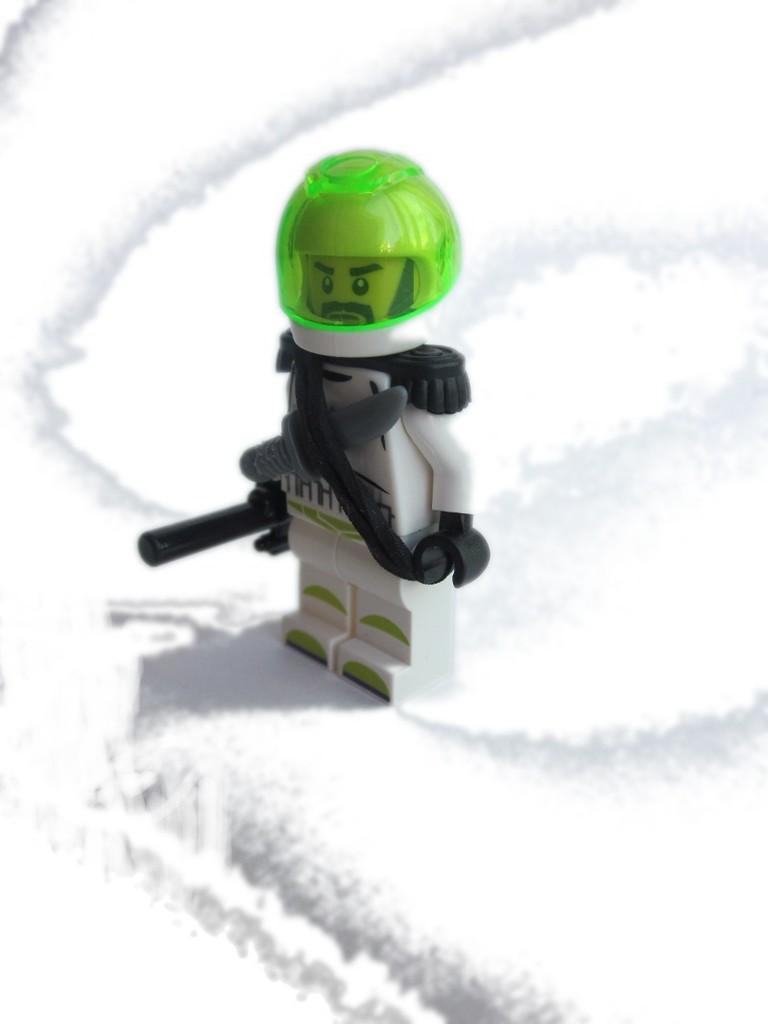Can you describe this image briefly? In this image I can see the toy which is in green, white, ash and black color. I can see the green color helmet to the toy. It is on the snow. 